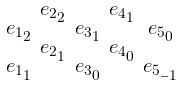<formula> <loc_0><loc_0><loc_500><loc_500>\begin{smallmatrix} & e _ { 2 _ { 2 } } & & e _ { 4 _ { 1 } } \\ e _ { 1 _ { 2 } } & & e _ { 3 _ { 1 } } & & e _ { 5 _ { 0 } } \\ & e _ { 2 _ { 1 } } & & e _ { 4 _ { 0 } } \\ e _ { 1 _ { 1 } } & & e _ { 3 _ { 0 } } & & e _ { 5 _ { - 1 } } \end{smallmatrix}</formula> 